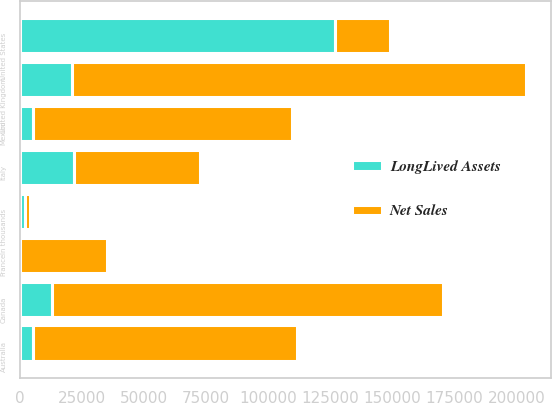Convert chart to OTSL. <chart><loc_0><loc_0><loc_500><loc_500><stacked_bar_chart><ecel><fcel>In thousands<fcel>United States<fcel>United Kingdom<fcel>Canada<fcel>Australia<fcel>Mexico<fcel>Italy<fcel>France<nl><fcel>Net Sales<fcel>2011<fcel>21937<fcel>182653<fcel>157379<fcel>106254<fcel>104384<fcel>50412<fcel>35199<nl><fcel>LongLived Assets<fcel>2011<fcel>126837<fcel>21046<fcel>12982<fcel>5075<fcel>5281<fcel>21937<fcel>15<nl></chart> 